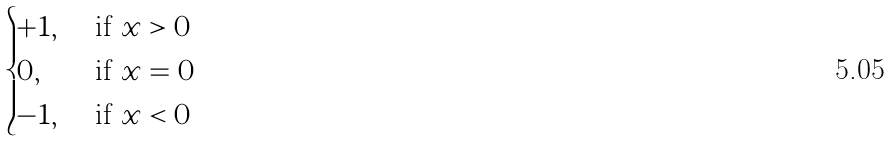<formula> <loc_0><loc_0><loc_500><loc_500>\begin{cases} + 1 , & \text { if } x > 0 \\ 0 , & \text { if } x = 0 \\ - 1 , & \text { if } x < 0 \end{cases}</formula> 